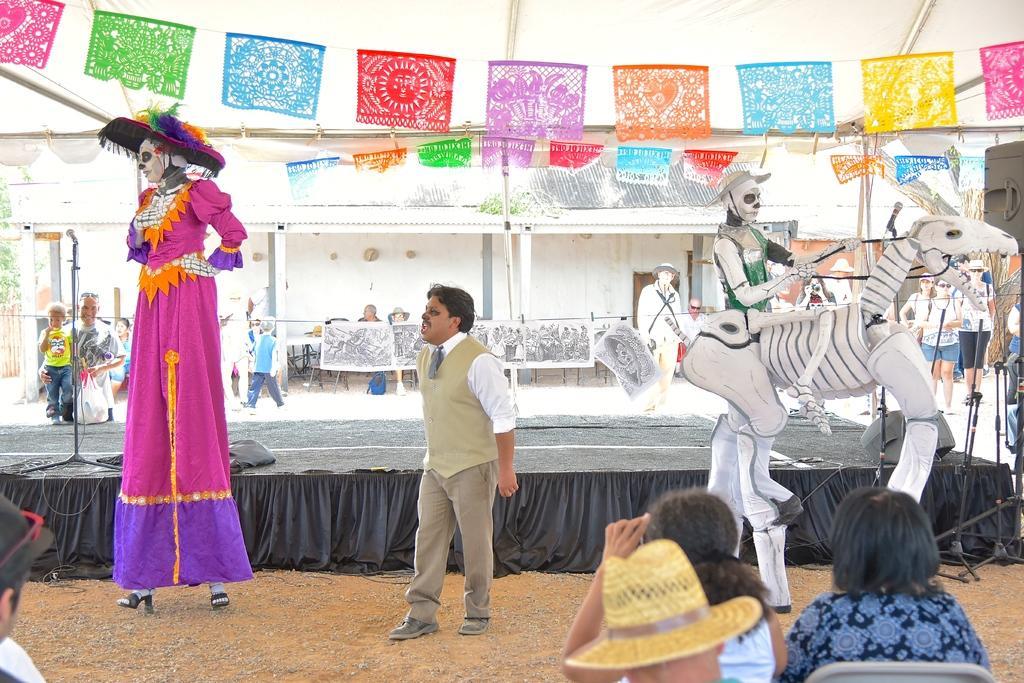Please provide a concise description of this image. In the image we can see there are people and children's. They are wearing clothes. Here we can see a skeleton of a person and a horse. Here we can see sand, stage, microphone and cable wires. Here we can see tables and a building. Here we can see fence, tree and decorative papers. 